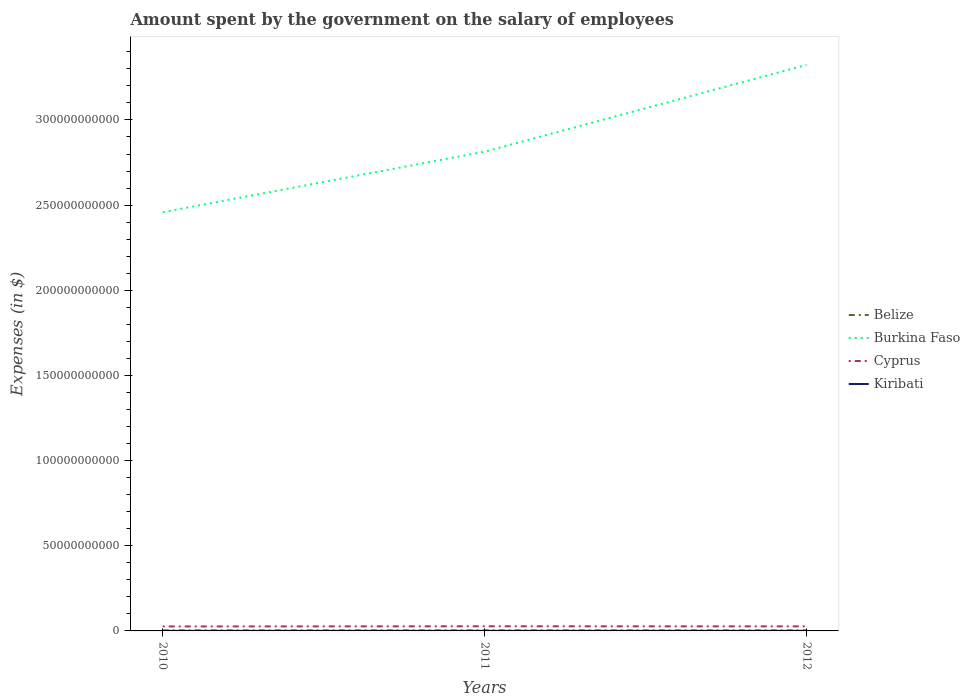Is the number of lines equal to the number of legend labels?
Give a very brief answer. Yes. Across all years, what is the maximum amount spent on the salary of employees by the government in Burkina Faso?
Ensure brevity in your answer.  2.46e+11. In which year was the amount spent on the salary of employees by the government in Burkina Faso maximum?
Your answer should be very brief. 2010. What is the total amount spent on the salary of employees by the government in Belize in the graph?
Give a very brief answer. -1.79e+07. What is the difference between the highest and the second highest amount spent on the salary of employees by the government in Burkina Faso?
Your response must be concise. 8.65e+1. What is the difference between the highest and the lowest amount spent on the salary of employees by the government in Belize?
Your response must be concise. 2. How many lines are there?
Ensure brevity in your answer.  4. How many years are there in the graph?
Provide a short and direct response. 3. How many legend labels are there?
Provide a short and direct response. 4. What is the title of the graph?
Make the answer very short. Amount spent by the government on the salary of employees. Does "Guinea-Bissau" appear as one of the legend labels in the graph?
Make the answer very short. No. What is the label or title of the X-axis?
Offer a terse response. Years. What is the label or title of the Y-axis?
Give a very brief answer. Expenses (in $). What is the Expenses (in $) in Belize in 2010?
Give a very brief answer. 2.79e+08. What is the Expenses (in $) of Burkina Faso in 2010?
Offer a terse response. 2.46e+11. What is the Expenses (in $) of Cyprus in 2010?
Give a very brief answer. 2.62e+09. What is the Expenses (in $) in Kiribati in 2010?
Give a very brief answer. 4.37e+07. What is the Expenses (in $) in Belize in 2011?
Provide a succinct answer. 2.96e+08. What is the Expenses (in $) in Burkina Faso in 2011?
Give a very brief answer. 2.81e+11. What is the Expenses (in $) of Cyprus in 2011?
Your answer should be very brief. 2.73e+09. What is the Expenses (in $) of Kiribati in 2011?
Offer a very short reply. 4.76e+07. What is the Expenses (in $) in Belize in 2012?
Your response must be concise. 2.97e+08. What is the Expenses (in $) of Burkina Faso in 2012?
Ensure brevity in your answer.  3.32e+11. What is the Expenses (in $) in Cyprus in 2012?
Keep it short and to the point. 2.68e+09. What is the Expenses (in $) in Kiribati in 2012?
Ensure brevity in your answer.  4.79e+07. Across all years, what is the maximum Expenses (in $) in Belize?
Your answer should be very brief. 2.97e+08. Across all years, what is the maximum Expenses (in $) of Burkina Faso?
Your response must be concise. 3.32e+11. Across all years, what is the maximum Expenses (in $) of Cyprus?
Provide a succinct answer. 2.73e+09. Across all years, what is the maximum Expenses (in $) in Kiribati?
Your answer should be compact. 4.79e+07. Across all years, what is the minimum Expenses (in $) in Belize?
Your response must be concise. 2.79e+08. Across all years, what is the minimum Expenses (in $) of Burkina Faso?
Make the answer very short. 2.46e+11. Across all years, what is the minimum Expenses (in $) of Cyprus?
Offer a terse response. 2.62e+09. Across all years, what is the minimum Expenses (in $) of Kiribati?
Your response must be concise. 4.37e+07. What is the total Expenses (in $) of Belize in the graph?
Give a very brief answer. 8.72e+08. What is the total Expenses (in $) of Burkina Faso in the graph?
Keep it short and to the point. 8.60e+11. What is the total Expenses (in $) in Cyprus in the graph?
Ensure brevity in your answer.  8.03e+09. What is the total Expenses (in $) in Kiribati in the graph?
Ensure brevity in your answer.  1.39e+08. What is the difference between the Expenses (in $) in Belize in 2010 and that in 2011?
Make the answer very short. -1.74e+07. What is the difference between the Expenses (in $) in Burkina Faso in 2010 and that in 2011?
Keep it short and to the point. -3.56e+1. What is the difference between the Expenses (in $) in Cyprus in 2010 and that in 2011?
Provide a succinct answer. -1.04e+08. What is the difference between the Expenses (in $) in Kiribati in 2010 and that in 2011?
Give a very brief answer. -3.90e+06. What is the difference between the Expenses (in $) of Belize in 2010 and that in 2012?
Provide a short and direct response. -1.79e+07. What is the difference between the Expenses (in $) of Burkina Faso in 2010 and that in 2012?
Your answer should be very brief. -8.65e+1. What is the difference between the Expenses (in $) of Cyprus in 2010 and that in 2012?
Give a very brief answer. -5.59e+07. What is the difference between the Expenses (in $) in Kiribati in 2010 and that in 2012?
Give a very brief answer. -4.15e+06. What is the difference between the Expenses (in $) in Belize in 2011 and that in 2012?
Your answer should be very brief. -5.55e+05. What is the difference between the Expenses (in $) in Burkina Faso in 2011 and that in 2012?
Make the answer very short. -5.10e+1. What is the difference between the Expenses (in $) in Cyprus in 2011 and that in 2012?
Provide a short and direct response. 4.84e+07. What is the difference between the Expenses (in $) in Kiribati in 2011 and that in 2012?
Your answer should be very brief. -2.51e+05. What is the difference between the Expenses (in $) of Belize in 2010 and the Expenses (in $) of Burkina Faso in 2011?
Your response must be concise. -2.81e+11. What is the difference between the Expenses (in $) in Belize in 2010 and the Expenses (in $) in Cyprus in 2011?
Give a very brief answer. -2.45e+09. What is the difference between the Expenses (in $) of Belize in 2010 and the Expenses (in $) of Kiribati in 2011?
Your answer should be very brief. 2.31e+08. What is the difference between the Expenses (in $) in Burkina Faso in 2010 and the Expenses (in $) in Cyprus in 2011?
Offer a terse response. 2.43e+11. What is the difference between the Expenses (in $) of Burkina Faso in 2010 and the Expenses (in $) of Kiribati in 2011?
Offer a terse response. 2.46e+11. What is the difference between the Expenses (in $) of Cyprus in 2010 and the Expenses (in $) of Kiribati in 2011?
Offer a very short reply. 2.57e+09. What is the difference between the Expenses (in $) in Belize in 2010 and the Expenses (in $) in Burkina Faso in 2012?
Your answer should be compact. -3.32e+11. What is the difference between the Expenses (in $) of Belize in 2010 and the Expenses (in $) of Cyprus in 2012?
Your answer should be compact. -2.40e+09. What is the difference between the Expenses (in $) in Belize in 2010 and the Expenses (in $) in Kiribati in 2012?
Offer a terse response. 2.31e+08. What is the difference between the Expenses (in $) of Burkina Faso in 2010 and the Expenses (in $) of Cyprus in 2012?
Offer a terse response. 2.43e+11. What is the difference between the Expenses (in $) in Burkina Faso in 2010 and the Expenses (in $) in Kiribati in 2012?
Give a very brief answer. 2.46e+11. What is the difference between the Expenses (in $) of Cyprus in 2010 and the Expenses (in $) of Kiribati in 2012?
Offer a terse response. 2.57e+09. What is the difference between the Expenses (in $) of Belize in 2011 and the Expenses (in $) of Burkina Faso in 2012?
Your answer should be very brief. -3.32e+11. What is the difference between the Expenses (in $) in Belize in 2011 and the Expenses (in $) in Cyprus in 2012?
Your answer should be very brief. -2.38e+09. What is the difference between the Expenses (in $) of Belize in 2011 and the Expenses (in $) of Kiribati in 2012?
Give a very brief answer. 2.49e+08. What is the difference between the Expenses (in $) of Burkina Faso in 2011 and the Expenses (in $) of Cyprus in 2012?
Offer a very short reply. 2.79e+11. What is the difference between the Expenses (in $) in Burkina Faso in 2011 and the Expenses (in $) in Kiribati in 2012?
Your answer should be very brief. 2.81e+11. What is the difference between the Expenses (in $) of Cyprus in 2011 and the Expenses (in $) of Kiribati in 2012?
Offer a terse response. 2.68e+09. What is the average Expenses (in $) in Belize per year?
Ensure brevity in your answer.  2.91e+08. What is the average Expenses (in $) of Burkina Faso per year?
Give a very brief answer. 2.87e+11. What is the average Expenses (in $) in Cyprus per year?
Provide a succinct answer. 2.68e+09. What is the average Expenses (in $) in Kiribati per year?
Give a very brief answer. 4.64e+07. In the year 2010, what is the difference between the Expenses (in $) in Belize and Expenses (in $) in Burkina Faso?
Give a very brief answer. -2.46e+11. In the year 2010, what is the difference between the Expenses (in $) of Belize and Expenses (in $) of Cyprus?
Your answer should be compact. -2.34e+09. In the year 2010, what is the difference between the Expenses (in $) of Belize and Expenses (in $) of Kiribati?
Make the answer very short. 2.35e+08. In the year 2010, what is the difference between the Expenses (in $) in Burkina Faso and Expenses (in $) in Cyprus?
Your response must be concise. 2.43e+11. In the year 2010, what is the difference between the Expenses (in $) of Burkina Faso and Expenses (in $) of Kiribati?
Offer a very short reply. 2.46e+11. In the year 2010, what is the difference between the Expenses (in $) of Cyprus and Expenses (in $) of Kiribati?
Ensure brevity in your answer.  2.58e+09. In the year 2011, what is the difference between the Expenses (in $) of Belize and Expenses (in $) of Burkina Faso?
Make the answer very short. -2.81e+11. In the year 2011, what is the difference between the Expenses (in $) in Belize and Expenses (in $) in Cyprus?
Your response must be concise. -2.43e+09. In the year 2011, what is the difference between the Expenses (in $) of Belize and Expenses (in $) of Kiribati?
Offer a very short reply. 2.49e+08. In the year 2011, what is the difference between the Expenses (in $) of Burkina Faso and Expenses (in $) of Cyprus?
Provide a succinct answer. 2.79e+11. In the year 2011, what is the difference between the Expenses (in $) in Burkina Faso and Expenses (in $) in Kiribati?
Provide a succinct answer. 2.81e+11. In the year 2011, what is the difference between the Expenses (in $) of Cyprus and Expenses (in $) of Kiribati?
Your answer should be compact. 2.68e+09. In the year 2012, what is the difference between the Expenses (in $) in Belize and Expenses (in $) in Burkina Faso?
Ensure brevity in your answer.  -3.32e+11. In the year 2012, what is the difference between the Expenses (in $) in Belize and Expenses (in $) in Cyprus?
Provide a short and direct response. -2.38e+09. In the year 2012, what is the difference between the Expenses (in $) in Belize and Expenses (in $) in Kiribati?
Keep it short and to the point. 2.49e+08. In the year 2012, what is the difference between the Expenses (in $) in Burkina Faso and Expenses (in $) in Cyprus?
Provide a succinct answer. 3.30e+11. In the year 2012, what is the difference between the Expenses (in $) of Burkina Faso and Expenses (in $) of Kiribati?
Ensure brevity in your answer.  3.32e+11. In the year 2012, what is the difference between the Expenses (in $) in Cyprus and Expenses (in $) in Kiribati?
Ensure brevity in your answer.  2.63e+09. What is the ratio of the Expenses (in $) of Belize in 2010 to that in 2011?
Provide a succinct answer. 0.94. What is the ratio of the Expenses (in $) of Burkina Faso in 2010 to that in 2011?
Ensure brevity in your answer.  0.87. What is the ratio of the Expenses (in $) in Cyprus in 2010 to that in 2011?
Offer a very short reply. 0.96. What is the ratio of the Expenses (in $) in Kiribati in 2010 to that in 2011?
Your answer should be compact. 0.92. What is the ratio of the Expenses (in $) of Belize in 2010 to that in 2012?
Ensure brevity in your answer.  0.94. What is the ratio of the Expenses (in $) of Burkina Faso in 2010 to that in 2012?
Your answer should be compact. 0.74. What is the ratio of the Expenses (in $) of Cyprus in 2010 to that in 2012?
Provide a short and direct response. 0.98. What is the ratio of the Expenses (in $) in Kiribati in 2010 to that in 2012?
Your answer should be very brief. 0.91. What is the ratio of the Expenses (in $) of Burkina Faso in 2011 to that in 2012?
Keep it short and to the point. 0.85. What is the ratio of the Expenses (in $) in Cyprus in 2011 to that in 2012?
Offer a very short reply. 1.02. What is the difference between the highest and the second highest Expenses (in $) of Belize?
Ensure brevity in your answer.  5.55e+05. What is the difference between the highest and the second highest Expenses (in $) of Burkina Faso?
Give a very brief answer. 5.10e+1. What is the difference between the highest and the second highest Expenses (in $) in Cyprus?
Your response must be concise. 4.84e+07. What is the difference between the highest and the second highest Expenses (in $) of Kiribati?
Ensure brevity in your answer.  2.51e+05. What is the difference between the highest and the lowest Expenses (in $) in Belize?
Provide a short and direct response. 1.79e+07. What is the difference between the highest and the lowest Expenses (in $) of Burkina Faso?
Make the answer very short. 8.65e+1. What is the difference between the highest and the lowest Expenses (in $) in Cyprus?
Offer a terse response. 1.04e+08. What is the difference between the highest and the lowest Expenses (in $) of Kiribati?
Ensure brevity in your answer.  4.15e+06. 